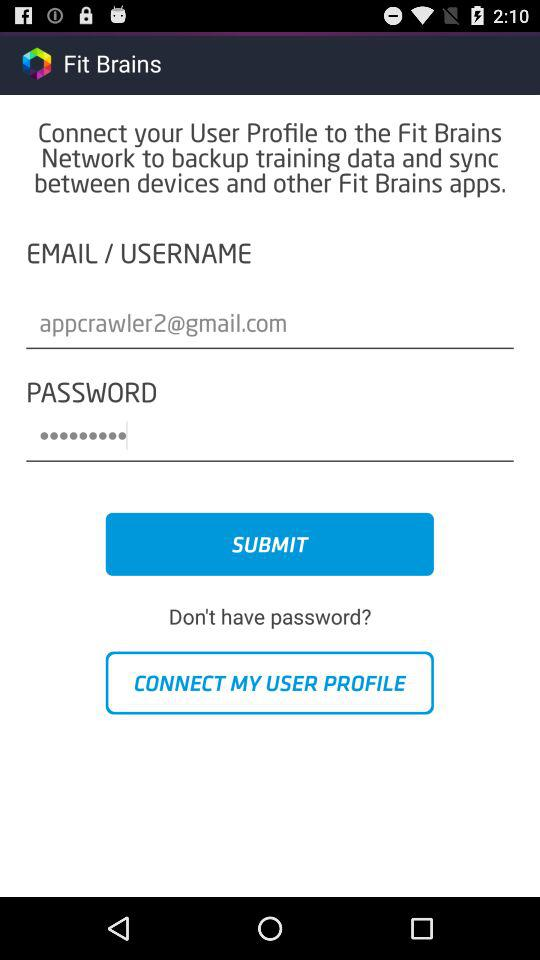What are the requirements for the password?
When the provided information is insufficient, respond with <no answer>. <no answer> 